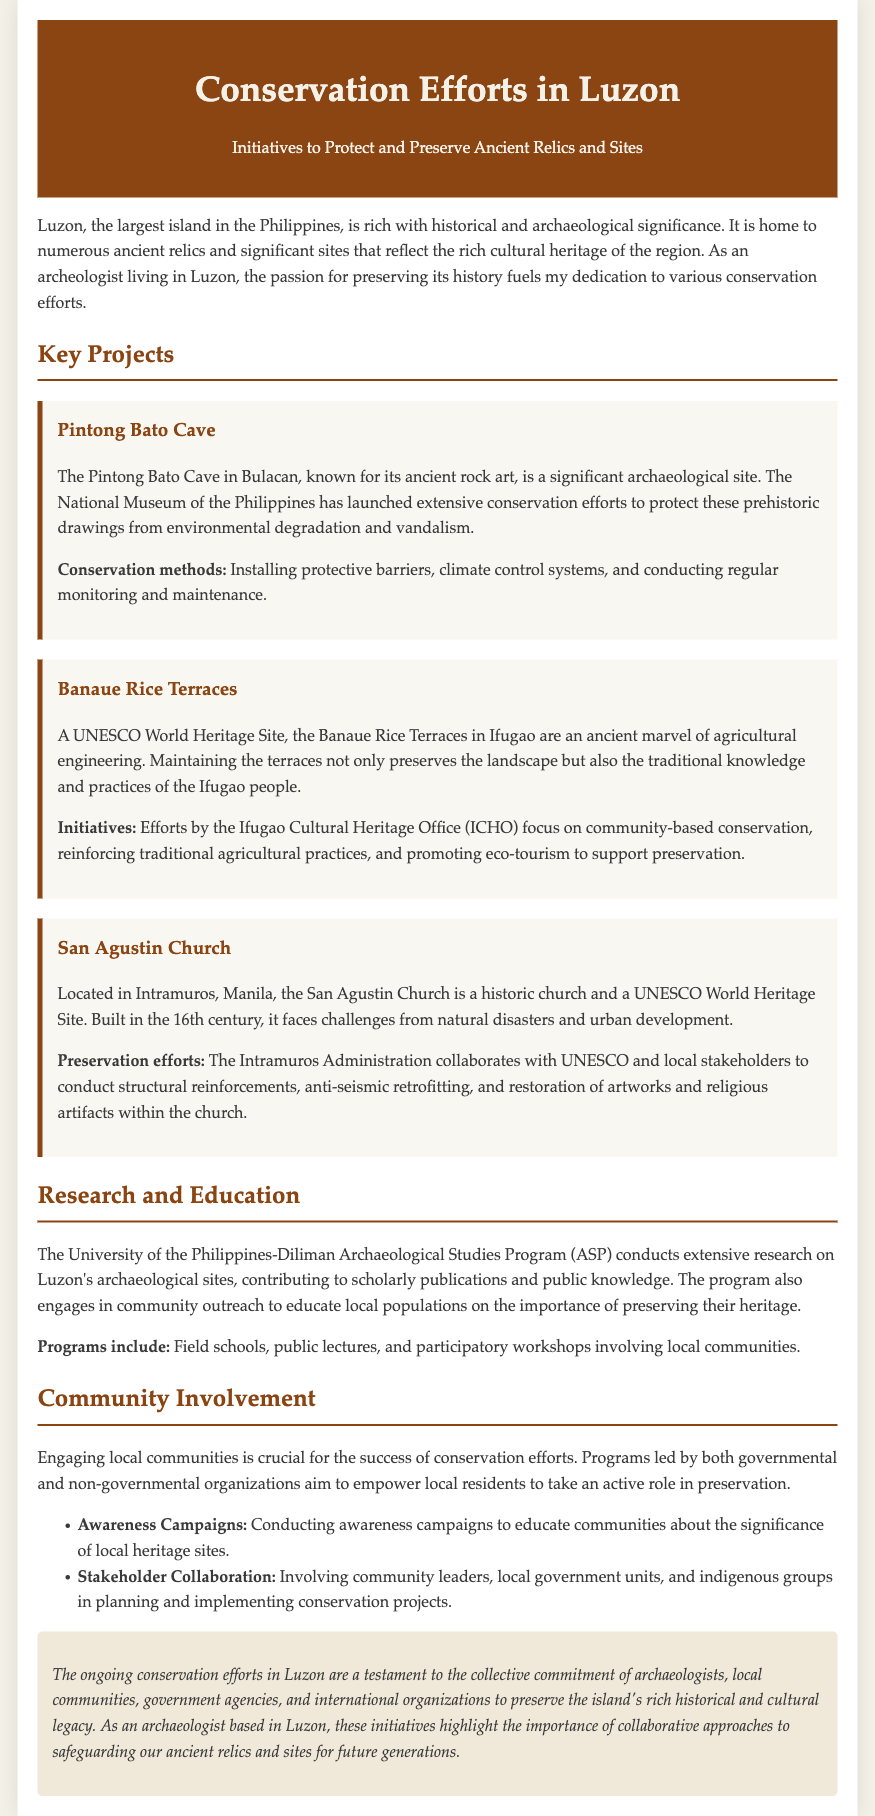What is the primary focus of the document? The primary focus of the document is on conservation efforts to protect and preserve ancient relics and sites in Luzon.
Answer: Conservation efforts Which cave is mentioned in the document? The document mentions Pintong Bato Cave located in Bulacan.
Answer: Pintong Bato Cave What UNESCO World Heritage Site is mentioned in relation to the Ifugao people? The document refers to the Banaue Rice Terraces as a UNESCO World Heritage Site related to the Ifugao people.
Answer: Banaue Rice Terraces Who conducts extensive research on Luzon's archaeological sites? The University of the Philippines-Diliman Archaeological Studies Program (ASP) conducts extensive research.
Answer: University of the Philippines-Diliman What kind of campaigns are conducted to educate communities about heritage sites? The document states that awareness campaigns are conducted for education about local heritage sites.
Answer: Awareness campaigns What type of collaboration is emphasized for the success of conservation efforts? The document emphasizes stakeholder collaboration involving community leaders and local government units.
Answer: Stakeholder collaboration What conservation method is used to protect the Pintong Bato Cave? The conservation method used includes installing protective barriers.
Answer: Installing protective barriers What significant challenge does the San Agustin Church face? The document states that the San Agustin Church faces challenges from natural disasters.
Answer: Natural disasters 